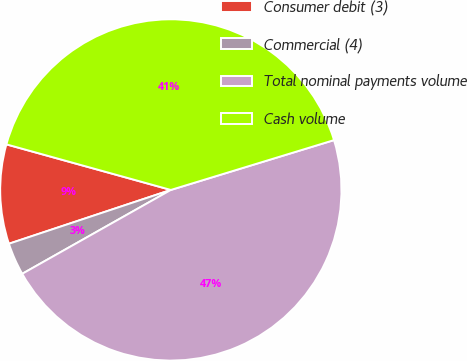Convert chart to OTSL. <chart><loc_0><loc_0><loc_500><loc_500><pie_chart><fcel>Consumer debit (3)<fcel>Commercial (4)<fcel>Total nominal payments volume<fcel>Cash volume<nl><fcel>9.41%<fcel>3.07%<fcel>46.54%<fcel>40.98%<nl></chart> 